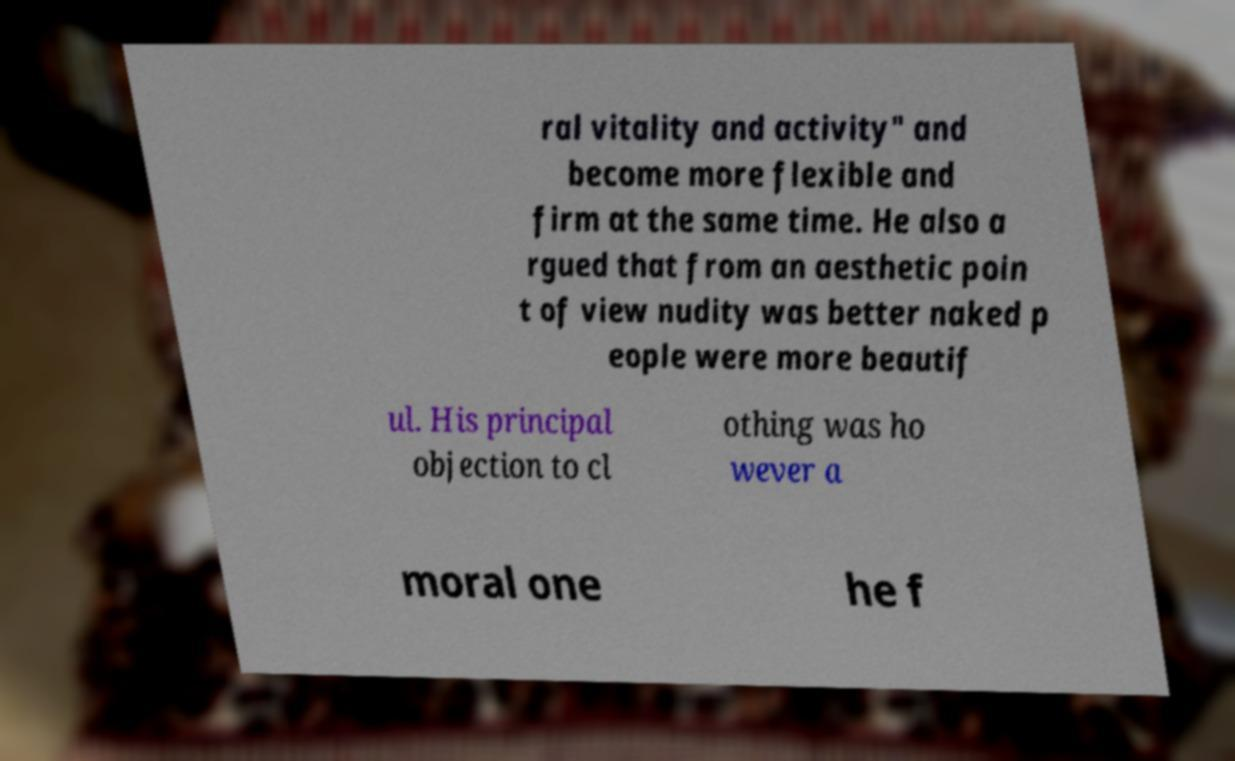Could you extract and type out the text from this image? ral vitality and activity" and become more flexible and firm at the same time. He also a rgued that from an aesthetic poin t of view nudity was better naked p eople were more beautif ul. His principal objection to cl othing was ho wever a moral one he f 